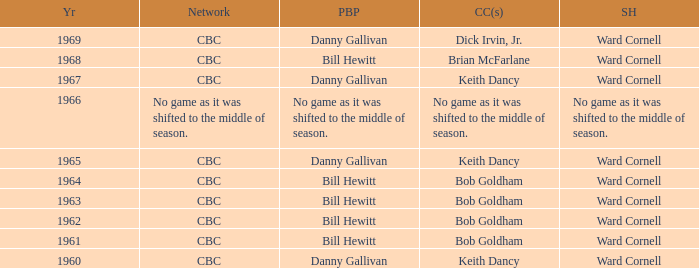When working with bill hewitt, did the color commentators participate in the play-by-play commentary? Brian McFarlane, Bob Goldham, Bob Goldham, Bob Goldham, Bob Goldham. Help me parse the entirety of this table. {'header': ['Yr', 'Network', 'PBP', 'CC(s)', 'SH'], 'rows': [['1969', 'CBC', 'Danny Gallivan', 'Dick Irvin, Jr.', 'Ward Cornell'], ['1968', 'CBC', 'Bill Hewitt', 'Brian McFarlane', 'Ward Cornell'], ['1967', 'CBC', 'Danny Gallivan', 'Keith Dancy', 'Ward Cornell'], ['1966', 'No game as it was shifted to the middle of season.', 'No game as it was shifted to the middle of season.', 'No game as it was shifted to the middle of season.', 'No game as it was shifted to the middle of season.'], ['1965', 'CBC', 'Danny Gallivan', 'Keith Dancy', 'Ward Cornell'], ['1964', 'CBC', 'Bill Hewitt', 'Bob Goldham', 'Ward Cornell'], ['1963', 'CBC', 'Bill Hewitt', 'Bob Goldham', 'Ward Cornell'], ['1962', 'CBC', 'Bill Hewitt', 'Bob Goldham', 'Ward Cornell'], ['1961', 'CBC', 'Bill Hewitt', 'Bob Goldham', 'Ward Cornell'], ['1960', 'CBC', 'Danny Gallivan', 'Keith Dancy', 'Ward Cornell']]} 